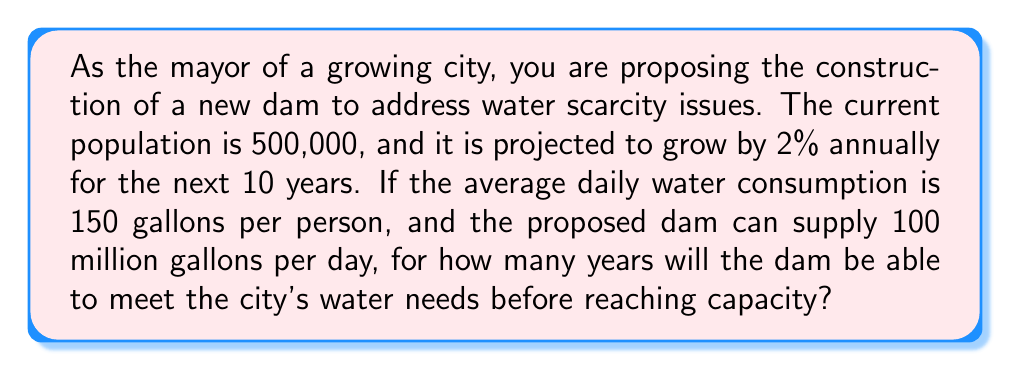Give your solution to this math problem. Let's approach this problem step-by-step:

1) First, we need to calculate the population after 10 years of 2% annual growth.
   We can use the compound growth formula:
   $$P_{10} = P_0 \times (1 + r)^n$$
   Where $P_{10}$ is the population after 10 years, $P_0$ is the initial population, $r$ is the growth rate, and $n$ is the number of years.

   $$P_{10} = 500,000 \times (1 + 0.02)^{10} \approx 609,496$$

2) Now, let's calculate the daily water demand after 10 years:
   $$\text{Daily Demand} = 609,496 \times 150 \approx 91,424,400 \text{ gallons}$$

3) The dam can supply 100 million gallons per day. To find how many years it will meet the demand, we need to calculate how long it will take for the demand to reach 100 million gallons.

4) We can set up an equation:
   $$500,000 \times (1 + 0.02)^x \times 150 = 100,000,000$$
   Where $x$ is the number of years we're solving for.

5) Simplifying:
   $$75,000,000 \times (1.02)^x = 100,000,000$$

6) Dividing both sides by 75,000,000:
   $$(1.02)^x = \frac{4}{3}$$

7) Taking the natural log of both sides:
   $$x \ln(1.02) = \ln(\frac{4}{3})$$

8) Solving for $x$:
   $$x = \frac{\ln(\frac{4}{3})}{\ln(1.02)} \approx 14.47$$

Therefore, the dam will meet the city's water needs for approximately 14.47 years before reaching capacity.
Answer: The dam will be able to meet the city's water needs for approximately 14.47 years before reaching capacity. 